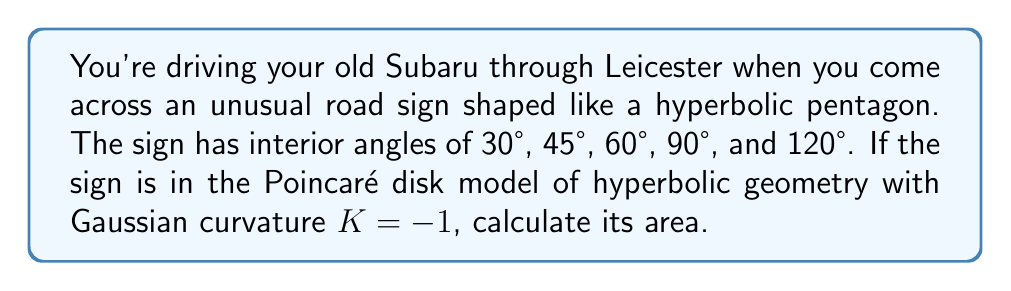What is the answer to this math problem? To solve this problem, we'll use the Gauss-Bonnet formula for hyperbolic polygons. Let's break it down step-by-step:

1) The Gauss-Bonnet formula for a hyperbolic polygon with $n$ sides is:

   $$A = (n-2)\pi - \sum_{i=1}^n \theta_i$$

   where $A$ is the area and $\theta_i$ are the interior angles.

2) We have a pentagon, so $n = 5$.

3) Let's sum the given interior angles:
   $$\sum_{i=1}^n \theta_i = 30° + 45° + 60° + 90° + 120° = 345°$$

4) Convert 345° to radians:
   $$345° \cdot \frac{\pi}{180°} = \frac{23\pi}{12}$$

5) Now, let's plug everything into the formula:

   $$A = (5-2)\pi - \frac{23\pi}{12}$$

6) Simplify:
   $$A = 3\pi - \frac{23\pi}{12} = \frac{36\pi}{12} - \frac{23\pi}{12} = \frac{13\pi}{12}$$

7) The area is given in terms of the squared radius of curvature. Since the Gaussian curvature $K = -1$, the radius of curvature is 1, so no further conversion is needed.
Answer: $\frac{13\pi}{12}$ 